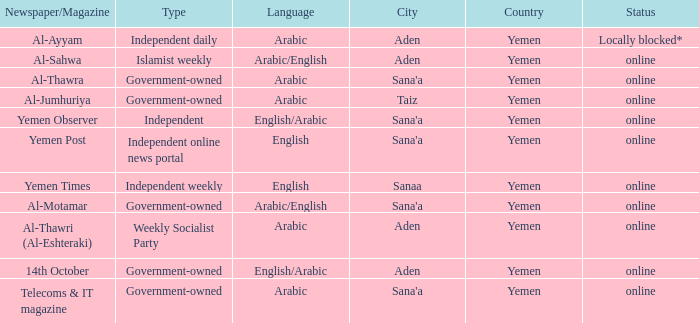What is Headquarter, when Newspaper/Magazine is Al-Ayyam? Aden. 